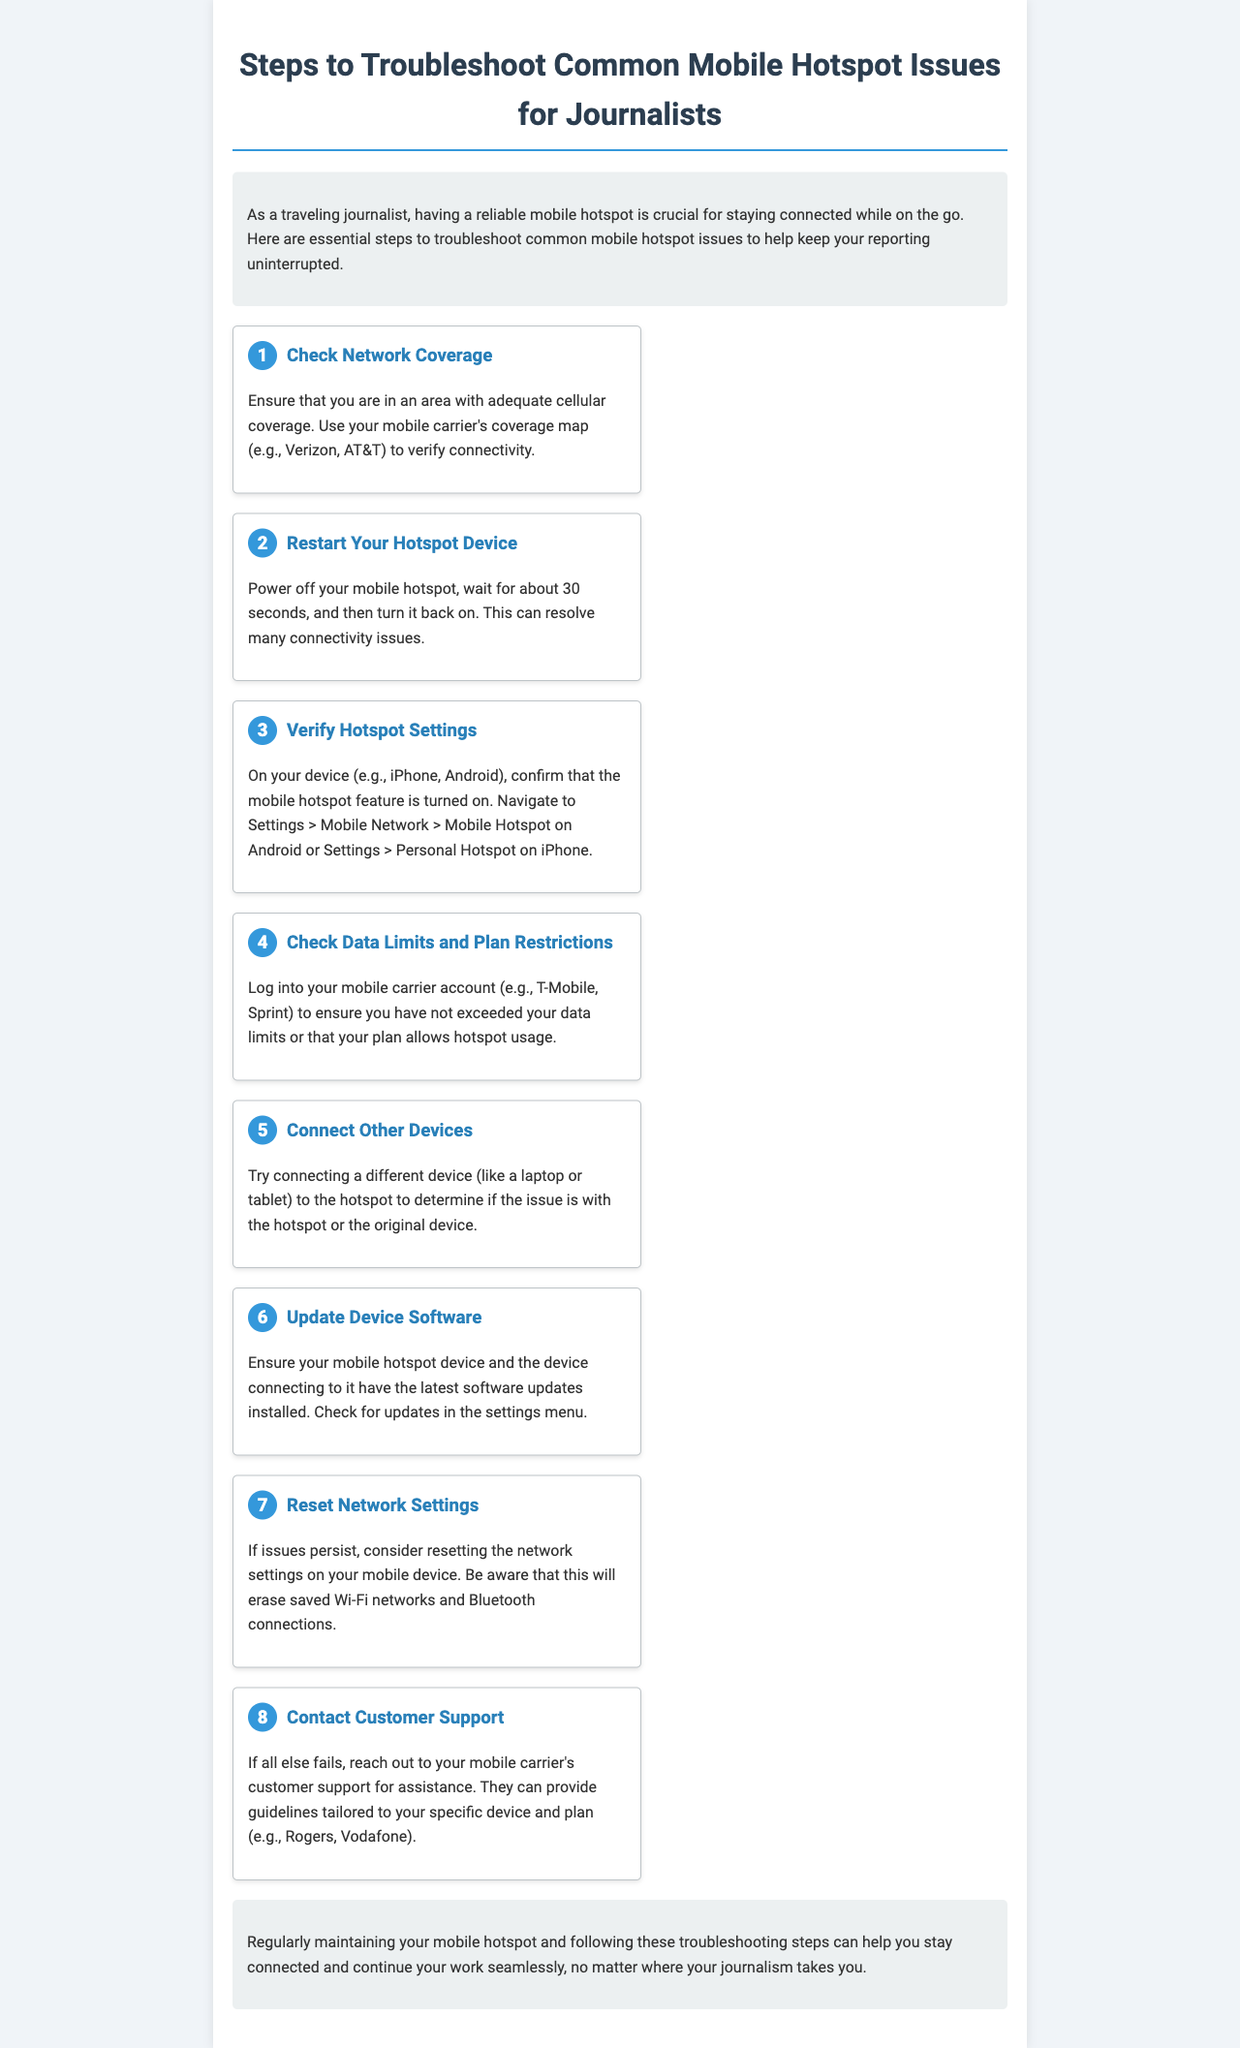What is the first step in troubleshooting mobile hotspot issues? The first step is always about checking network coverage in the area.
Answer: Check Network Coverage How many steps are listed in the document? There are a total of eight steps provided for troubleshooting.
Answer: 8 What should you do if the issue persists after updates? If issues persist, consider resetting the network settings on your mobile device.
Answer: Reset Network Settings What is the title of the document? The title of the document is clearly stated at the top.
Answer: Steps to Troubleshoot Common Mobile Hotspot Issues for Journalists Which devices are mentioned for checking hotspot settings? The devices mentioned include iPhone and Android for verifying hotspot settings.
Answer: iPhone, Android What should you do to verify data limits? You should log into your mobile carrier account to check for data limits.
Answer: Log into your mobile carrier account What action should you take if you cannot resolve the issue? If all else fails, you are advised to contact customer support for assistance.
Answer: Contact Customer Support How long should you wait before restarting your hotspot device? You should wait for about 30 seconds after powering it off before turning it back on.
Answer: 30 seconds 